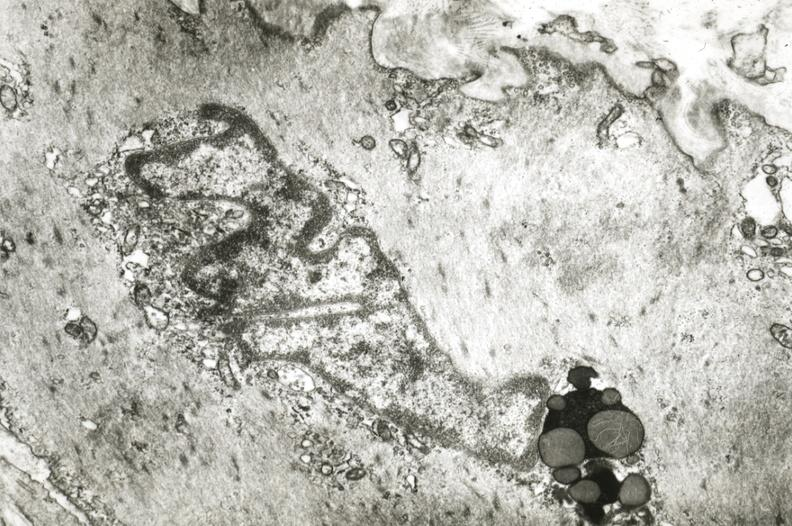does this image show intimal smooth muscle cell with lipochrome pigment?
Answer the question using a single word or phrase. Yes 